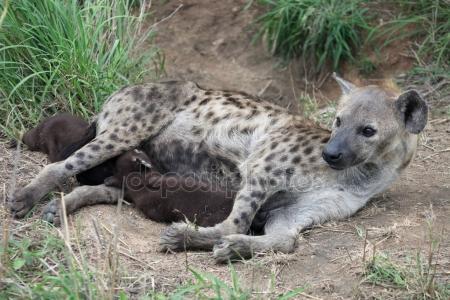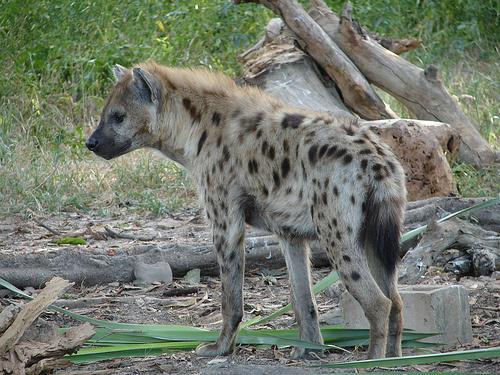The first image is the image on the left, the second image is the image on the right. Evaluate the accuracy of this statement regarding the images: "The left and right image contains the same number of hyenas with at least one being striped.". Is it true? Answer yes or no. No. 